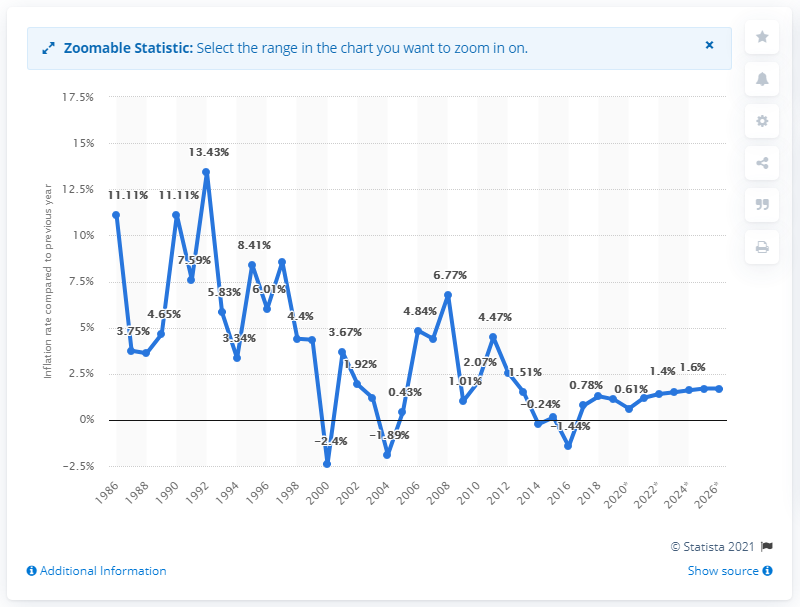Highlight a few significant elements in this photo. The average inflation rate in Cabo Verde was in 1986. In 2019, the inflation rate in Cabo Verde was 1.11%. 